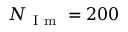<formula> <loc_0><loc_0><loc_500><loc_500>N _ { I m } = 2 0 0</formula> 